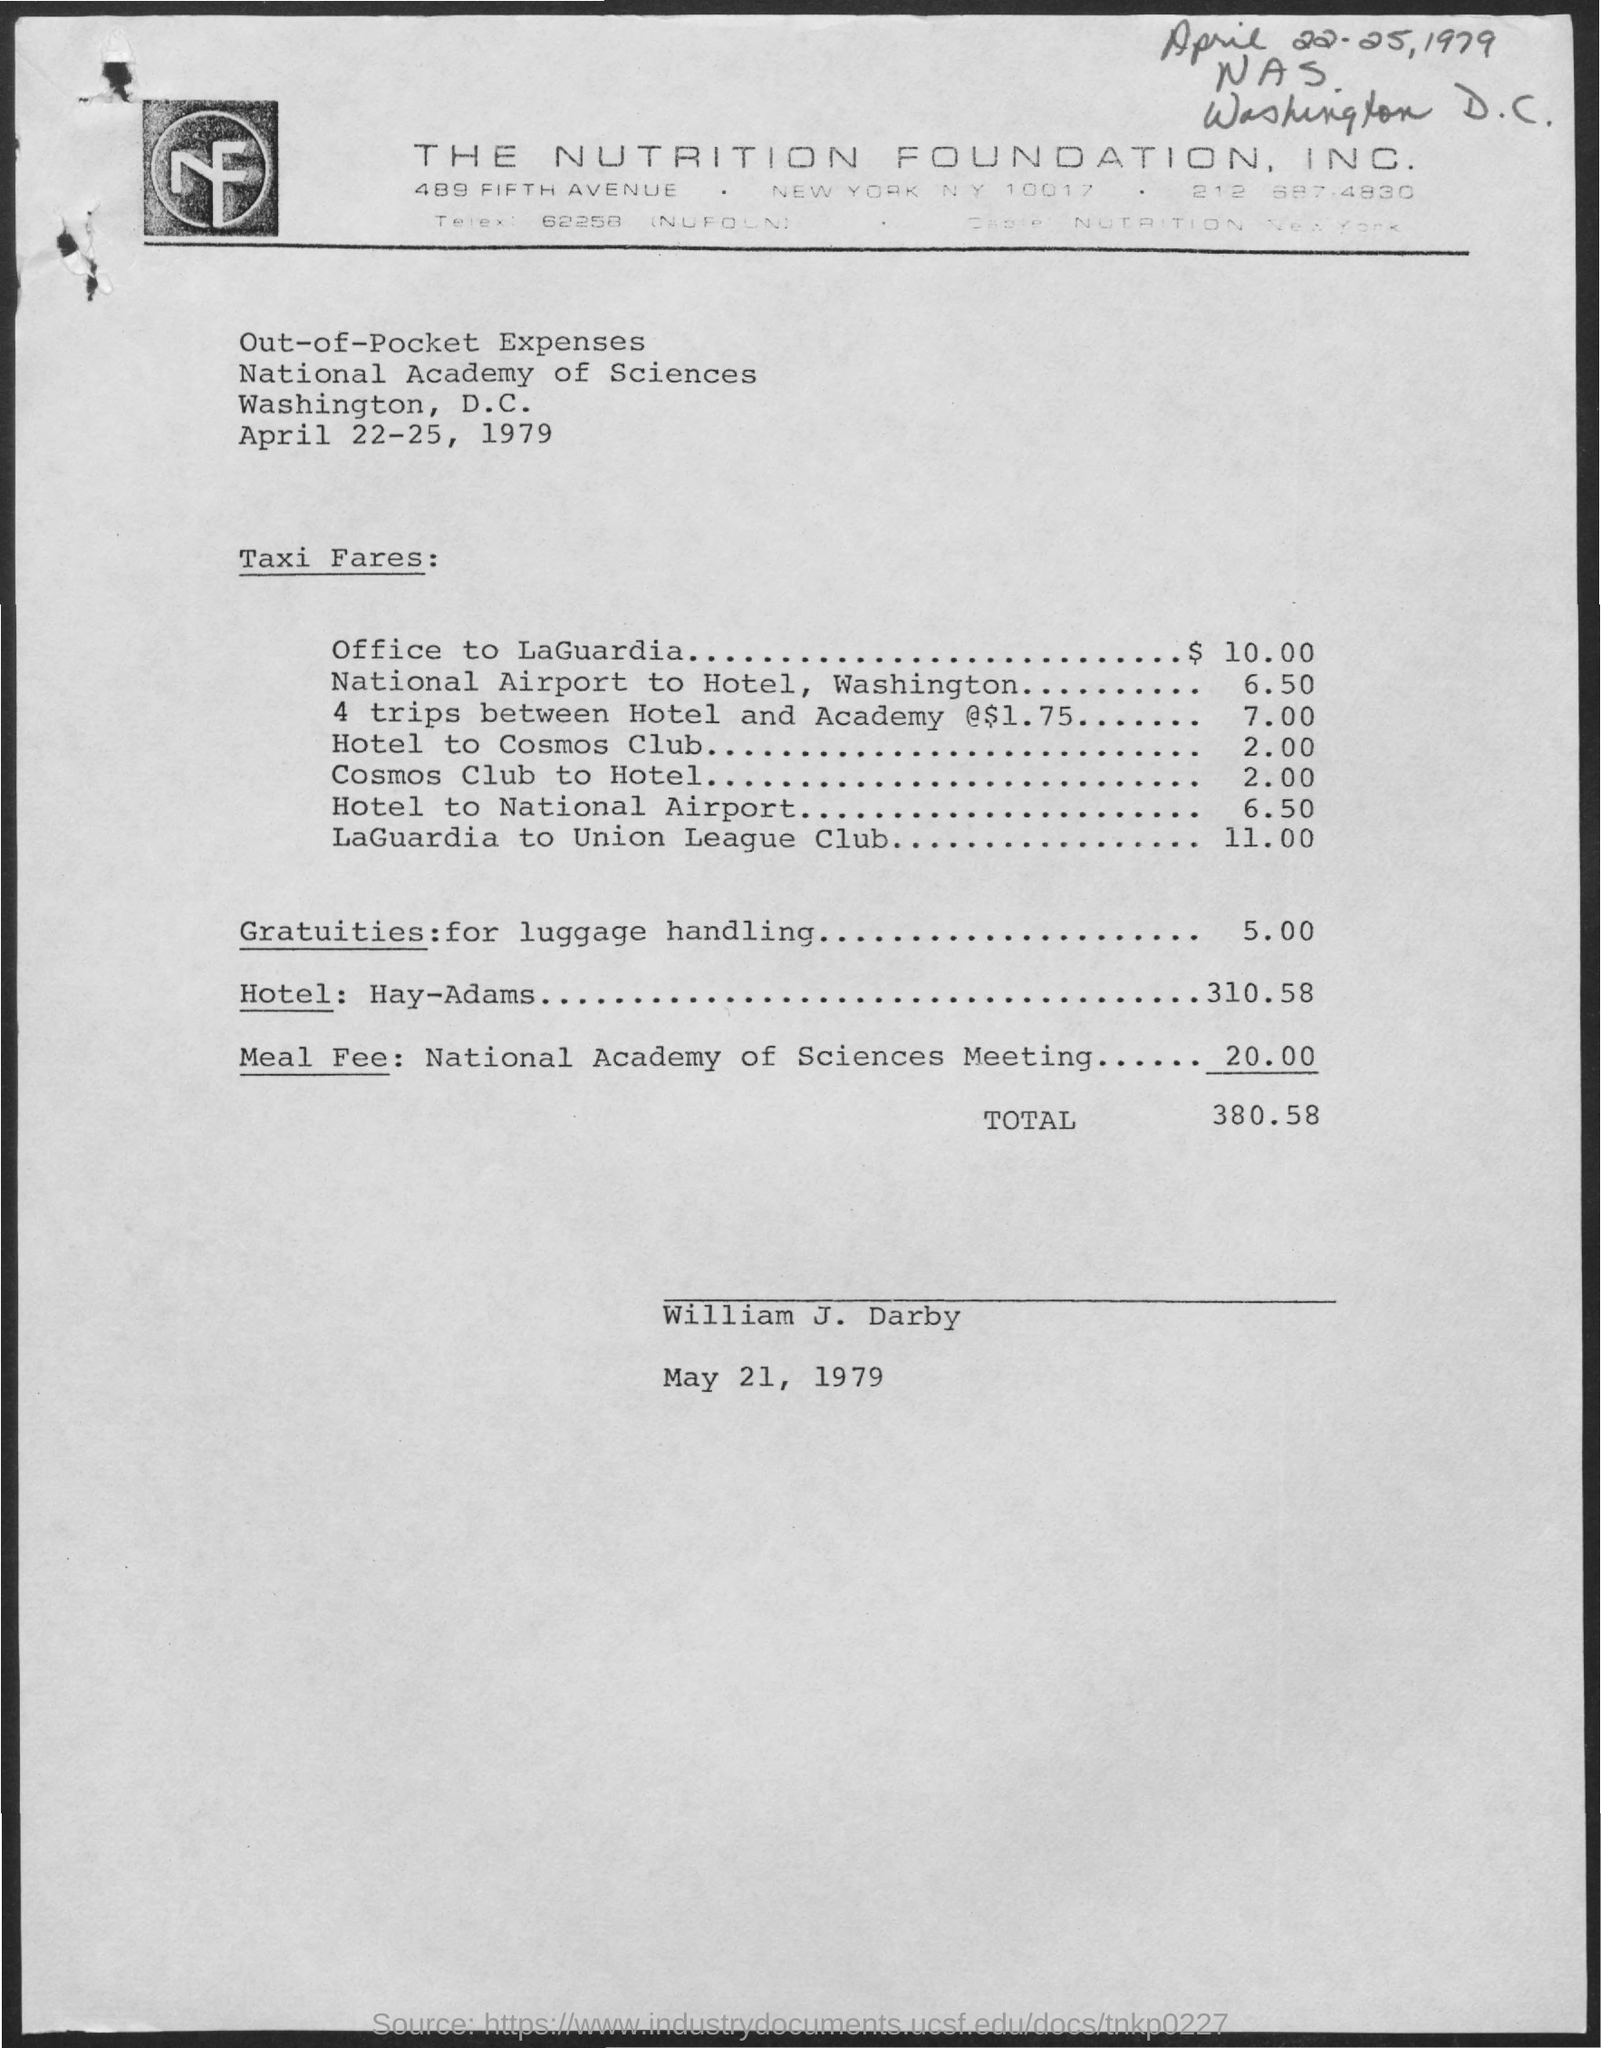What date is written at the top of the page?
Offer a very short reply. April 22-25, 1979. What is the taxi fare from Office to LaGuardia?
Provide a short and direct response. $ 10.00. What are the gratuities for luggage handling in $?
Give a very brief answer. 5 00. What is the total expense in $?
Ensure brevity in your answer.  380 58. 